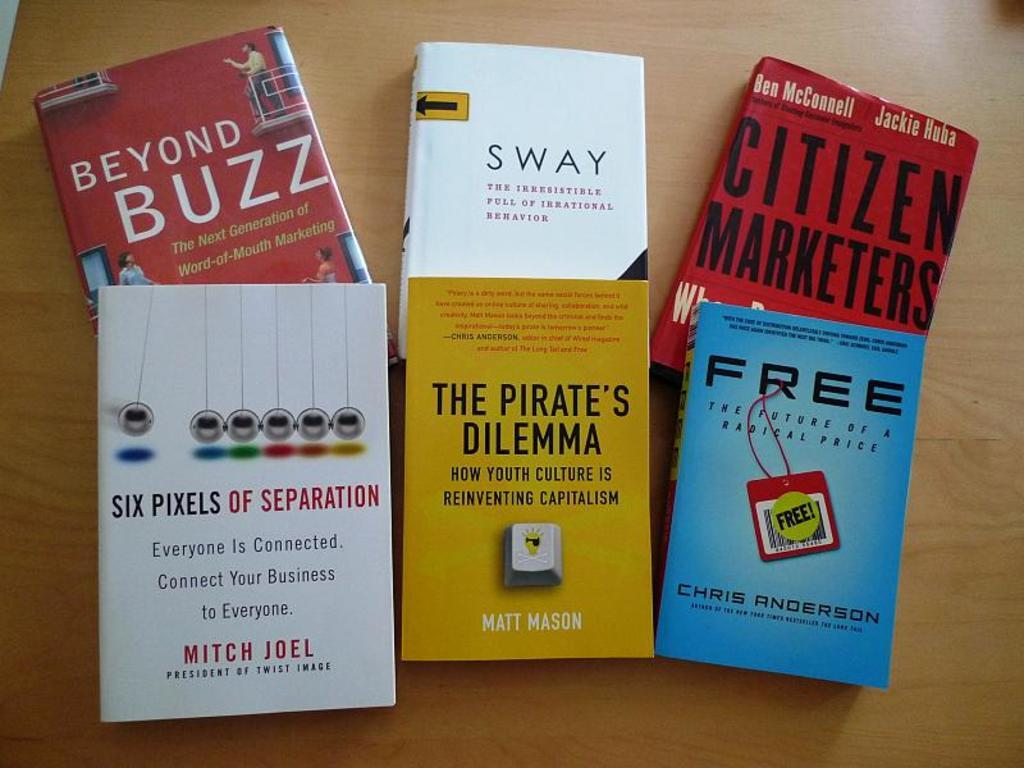<image>
Write a terse but informative summary of the picture. several books on a table including The Pirate's Dilemma 